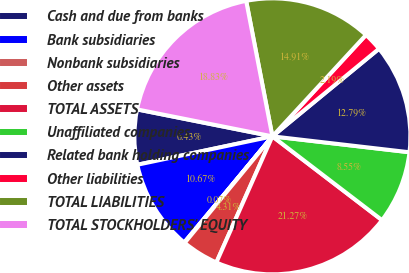Convert chart to OTSL. <chart><loc_0><loc_0><loc_500><loc_500><pie_chart><fcel>Cash and due from banks<fcel>Bank subsidiaries<fcel>Nonbank subsidiaries<fcel>Other assets<fcel>TOTAL ASSETS<fcel>Unaffiliated companies<fcel>Related bank holding companies<fcel>Other liabilities<fcel>TOTAL LIABILITIES<fcel>TOTAL STOCKHOLDERS' EQUITY<nl><fcel>6.43%<fcel>10.67%<fcel>0.07%<fcel>4.31%<fcel>21.27%<fcel>8.55%<fcel>12.79%<fcel>2.19%<fcel>14.91%<fcel>18.83%<nl></chart> 